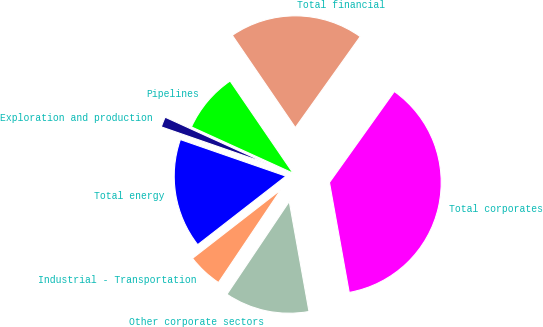<chart> <loc_0><loc_0><loc_500><loc_500><pie_chart><fcel>Total financial<fcel>Pipelines<fcel>Exploration and production<fcel>Total energy<fcel>Industrial - Transportation<fcel>Other corporate sectors<fcel>Total corporates<nl><fcel>19.4%<fcel>8.66%<fcel>1.49%<fcel>15.82%<fcel>5.08%<fcel>12.24%<fcel>37.31%<nl></chart> 